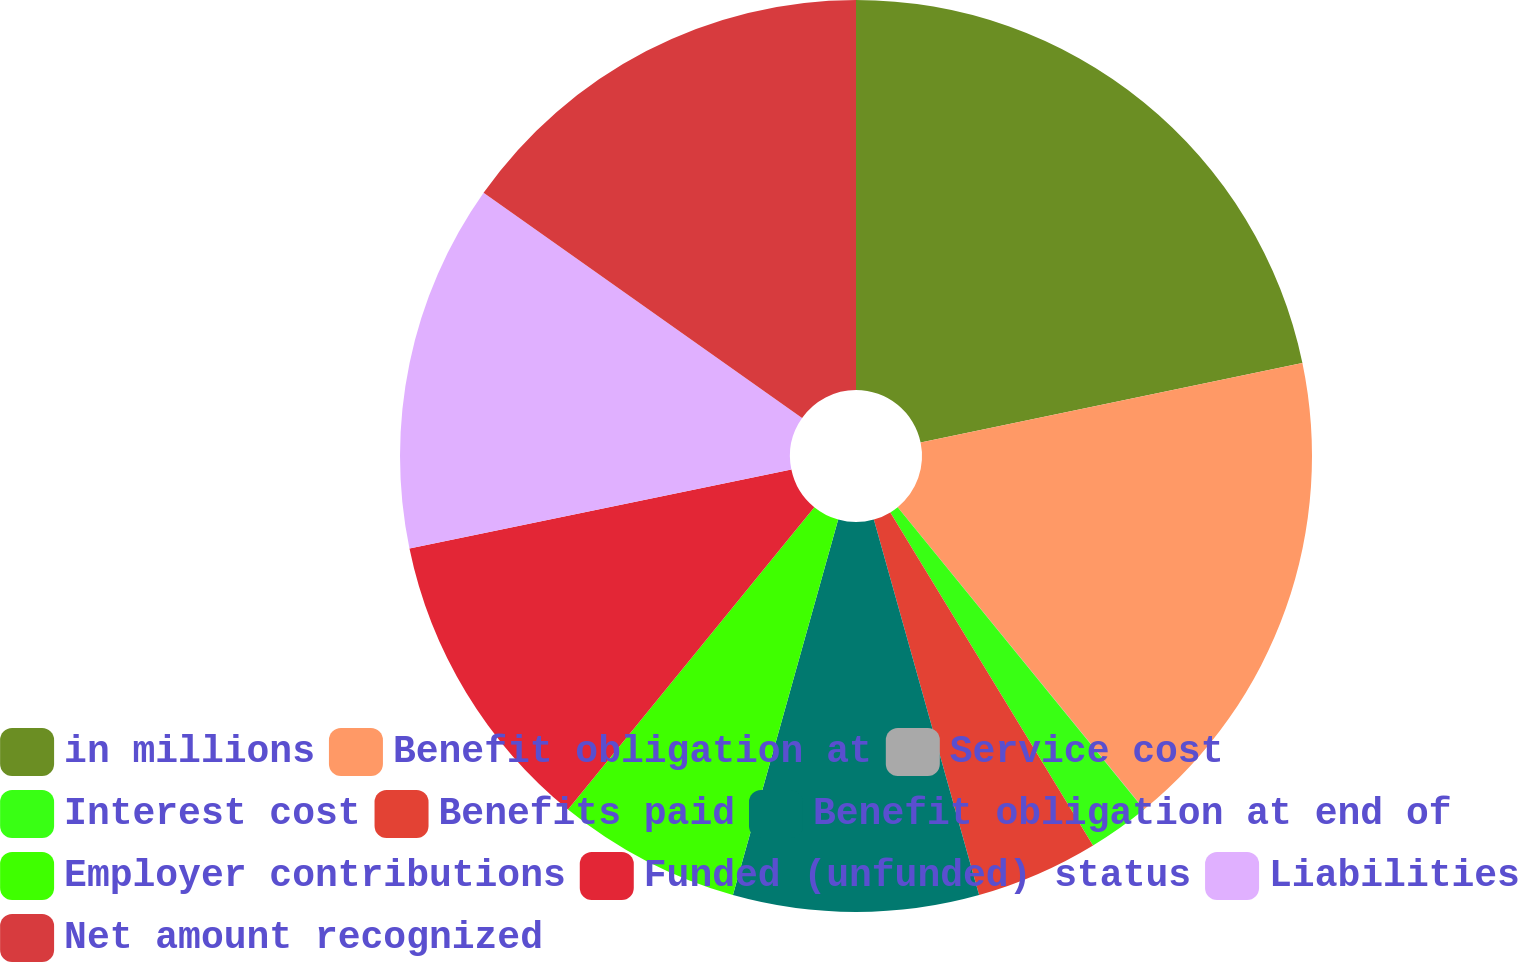Convert chart. <chart><loc_0><loc_0><loc_500><loc_500><pie_chart><fcel>in millions<fcel>Benefit obligation at<fcel>Service cost<fcel>Interest cost<fcel>Benefits paid<fcel>Benefit obligation at end of<fcel>Employer contributions<fcel>Funded (unfunded) status<fcel>Liabilities<fcel>Net amount recognized<nl><fcel>21.73%<fcel>17.38%<fcel>0.01%<fcel>2.18%<fcel>4.35%<fcel>8.7%<fcel>6.53%<fcel>10.87%<fcel>13.04%<fcel>15.21%<nl></chart> 